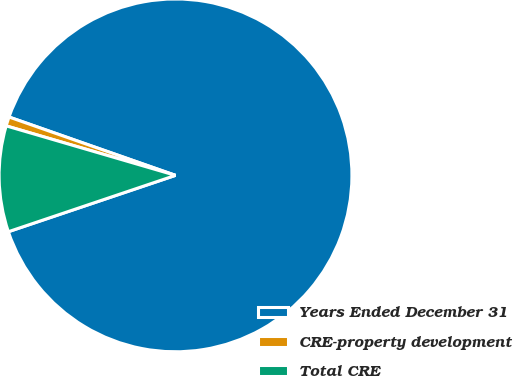Convert chart. <chart><loc_0><loc_0><loc_500><loc_500><pie_chart><fcel>Years Ended December 31<fcel>CRE-property development<fcel>Total CRE<nl><fcel>89.45%<fcel>0.84%<fcel>9.7%<nl></chart> 